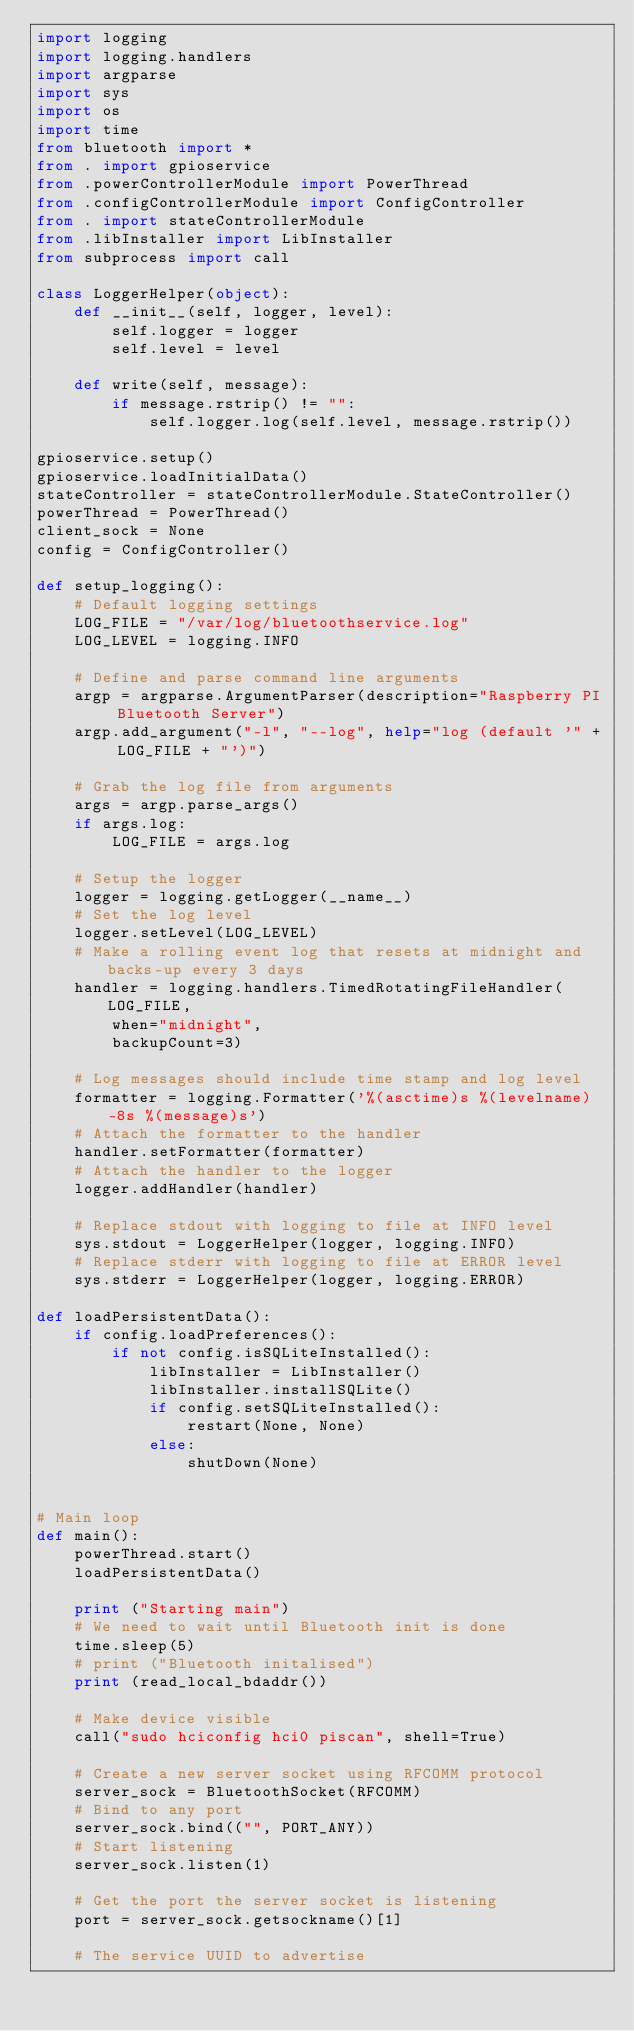<code> <loc_0><loc_0><loc_500><loc_500><_Python_>import logging
import logging.handlers
import argparse
import sys
import os
import time
from bluetooth import *
from . import gpioservice
from .powerControllerModule import PowerThread
from .configControllerModule import ConfigController
from . import stateControllerModule
from .libInstaller import LibInstaller
from subprocess import call

class LoggerHelper(object):
    def __init__(self, logger, level):
        self.logger = logger
        self.level = level

    def write(self, message):
        if message.rstrip() != "":
            self.logger.log(self.level, message.rstrip())

gpioservice.setup()
gpioservice.loadInitialData()
stateController = stateControllerModule.StateController()
powerThread = PowerThread()
client_sock = None
config = ConfigController()

def setup_logging():
    # Default logging settings
    LOG_FILE = "/var/log/bluetoothservice.log"
    LOG_LEVEL = logging.INFO

    # Define and parse command line arguments
    argp = argparse.ArgumentParser(description="Raspberry PI Bluetooth Server")
    argp.add_argument("-l", "--log", help="log (default '" + LOG_FILE + "')")

    # Grab the log file from arguments
    args = argp.parse_args()
    if args.log:
        LOG_FILE = args.log

    # Setup the logger
    logger = logging.getLogger(__name__)
    # Set the log level
    logger.setLevel(LOG_LEVEL)
    # Make a rolling event log that resets at midnight and backs-up every 3 days
    handler = logging.handlers.TimedRotatingFileHandler(LOG_FILE,
        when="midnight",
        backupCount=3)

    # Log messages should include time stamp and log level
    formatter = logging.Formatter('%(asctime)s %(levelname)-8s %(message)s')
    # Attach the formatter to the handler
    handler.setFormatter(formatter)
    # Attach the handler to the logger
    logger.addHandler(handler)

    # Replace stdout with logging to file at INFO level
    sys.stdout = LoggerHelper(logger, logging.INFO)
    # Replace stderr with logging to file at ERROR level
    sys.stderr = LoggerHelper(logger, logging.ERROR)

def loadPersistentData():
    if config.loadPreferences():
        if not config.isSQLiteInstalled():
            libInstaller = LibInstaller()
            libInstaller.installSQLite()
            if config.setSQLiteInstalled():
                restart(None, None)
            else: 
                shutDown(None)
    

# Main loop
def main():          
    powerThread.start()
    loadPersistentData()
    
    print ("Starting main")
    # We need to wait until Bluetooth init is done
    time.sleep(5)
    # print ("Bluetooth initalised")
    print (read_local_bdaddr())

    # Make device visible
    call("sudo hciconfig hci0 piscan", shell=True)

    # Create a new server socket using RFCOMM protocol
    server_sock = BluetoothSocket(RFCOMM)
    # Bind to any port
    server_sock.bind(("", PORT_ANY))
    # Start listening
    server_sock.listen(1)

    # Get the port the server socket is listening
    port = server_sock.getsockname()[1]

    # The service UUID to advertise</code> 